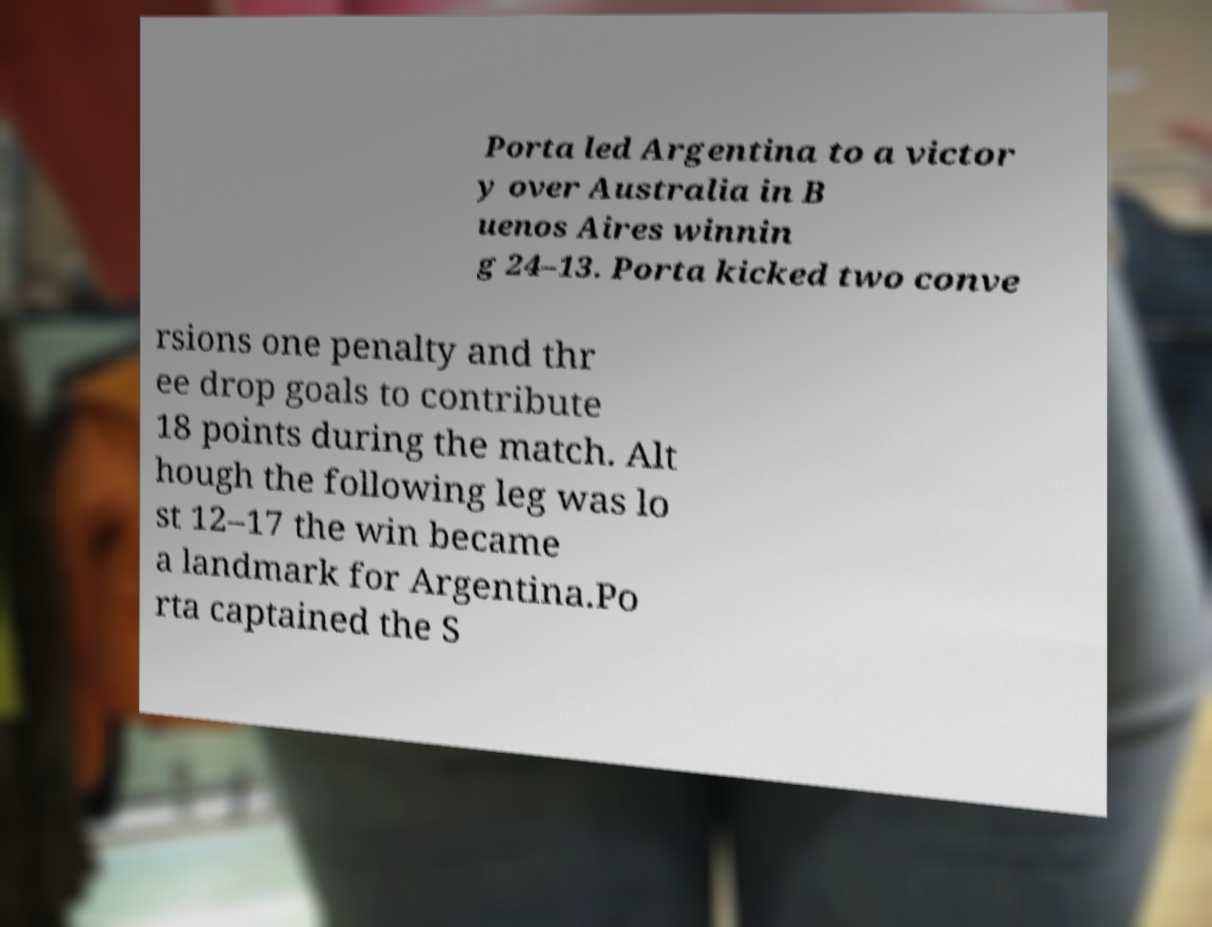I need the written content from this picture converted into text. Can you do that? Porta led Argentina to a victor y over Australia in B uenos Aires winnin g 24–13. Porta kicked two conve rsions one penalty and thr ee drop goals to contribute 18 points during the match. Alt hough the following leg was lo st 12–17 the win became a landmark for Argentina.Po rta captained the S 